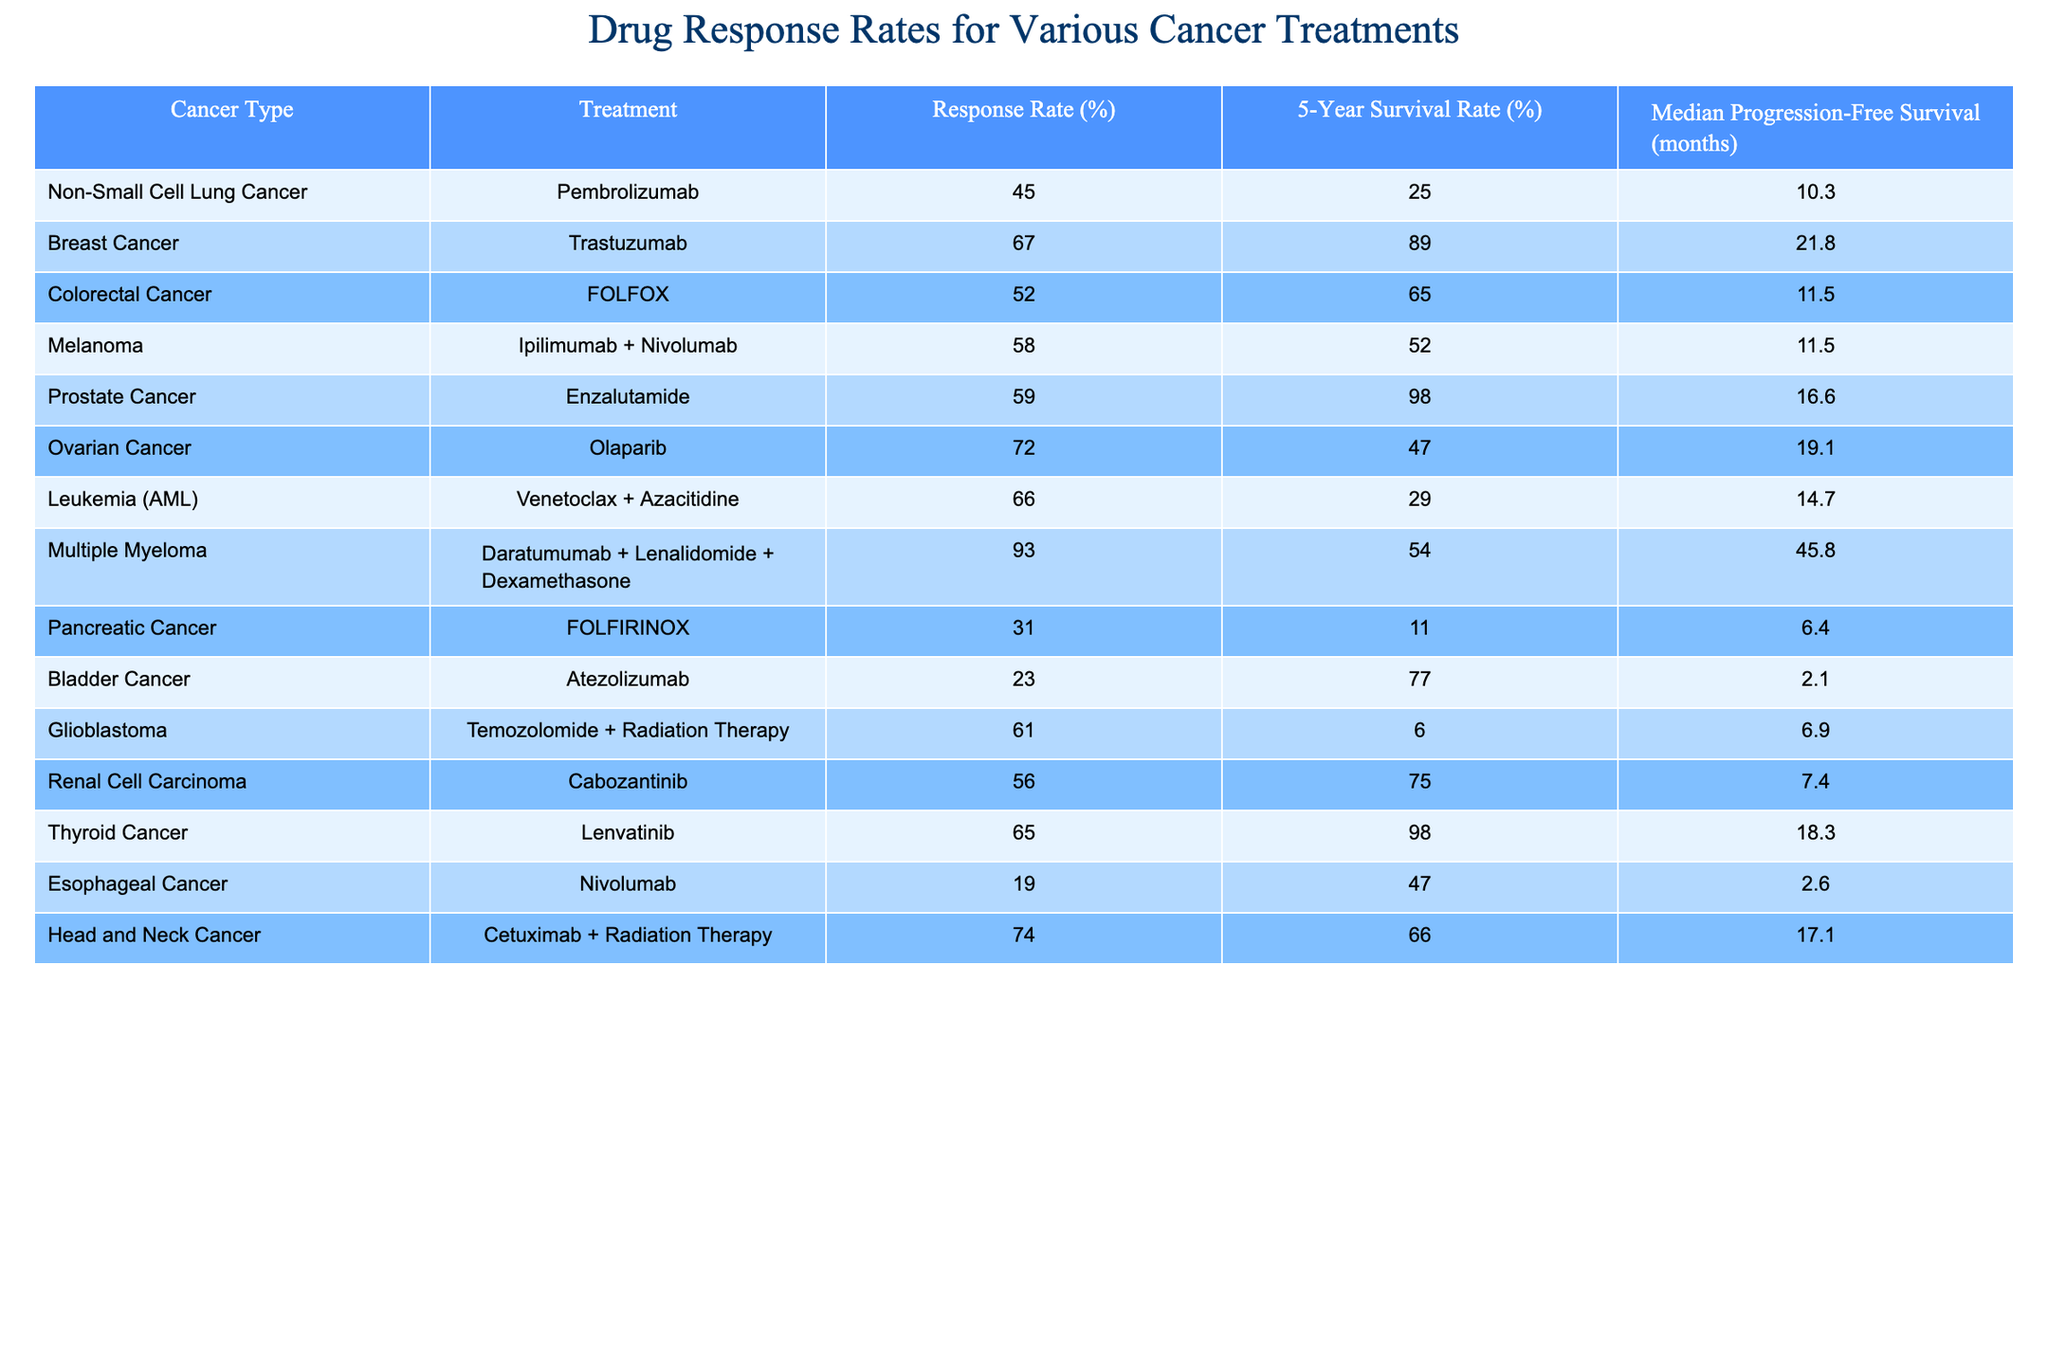What is the response rate for Ovarian Cancer treatment? The table indicates that the response rate for Olaparib, the treatment for Ovarian Cancer, is 72%.
Answer: 72% Which treatment has the highest response rate? According to the table, Multiple Myeloma treatment with Daratumumab + Lenalidomide + Dexamethasone has the highest response rate at 93%.
Answer: 93% What is the 5-Year Survival Rate for Breast Cancer treated with Trastuzumab? The table shows that the 5-Year Survival Rate for Breast Cancer when treated with Trastuzumab is 89%.
Answer: 89% Is the response rate for Colorectal Cancer higher than that for Pancreatic Cancer? The response rate for Colorectal Cancer is 52%, while for Pancreatic Cancer, it is 31%. Hence, it is true that Colorectal Cancer's response rate is higher.
Answer: Yes What is the average Median Progression-Free Survival for the cancers listed? To find the average, add the Median Progression-Free Survivor months for each treatment: (10.3 + 21.8 + 11.5 + 11.5 + 16.6 + 19.1 + 14.7 + 45.8 + 6.4 + 2.1 + 6.9 + 7.4 + 18.3 + 2.6 + 17.1) = 198.1. Dividing by 15 gives an average of 13.21 months.
Answer: 13.21 months What cancer treatment shows the lowest response rate? The table indicates that Atezolizumab, used for Bladder Cancer, shows the lowest response rate at 23%.
Answer: 23% Is the 5-Year Survival Rate for Non-Small Cell Lung Cancer lower than for Thyroid Cancer? The 5-Year Survival Rate for Non-Small Cell Lung Cancer is 25%, while for Thyroid Cancer it is 98%, indicating that Non-Small Cell Lung Cancer's rate is significantly lower.
Answer: Yes How many treatments listed have a response rate above 60%? The treatments with response rates above 60% are Ovarian Cancer (72%), Breast Cancer (67%), Leukemia (66%), Prostate Cancer (59%), Multiple Myeloma (93%), and Head and Neck Cancer (74%), making a total of 6 treatments.
Answer: 6 What is the difference in response rates between the most effective treatment and the least effective treatment? The most effective treatment is for Multiple Myeloma with a 93% response rate, and the least effective is for Atezolizumab (Bladder Cancer) with a 23% response rate. The difference is 93% - 23% = 70%.
Answer: 70% Which two cancers have a median progression-free survival time greater than 18 months? The cancers with a median progression-free survival time greater than 18 months are Breast Cancer (21.8 months) and Multiple Myeloma (45.8 months).
Answer: Breast Cancer and Multiple Myeloma Is it true that all treatments listed have a response rate above 20%? Looking at the table, the treatments for Bladder Cancer (23%) and Pancreatic Cancer (31%) both support that all other treatments have response rates above 20%. Thus, the statement is true.
Answer: Yes What cancer treatment has the longest median progression-free survival? The treatment for Multiple Myeloma shows the longest median progression-free survival time of 45.8 months.
Answer: 45.8 months 